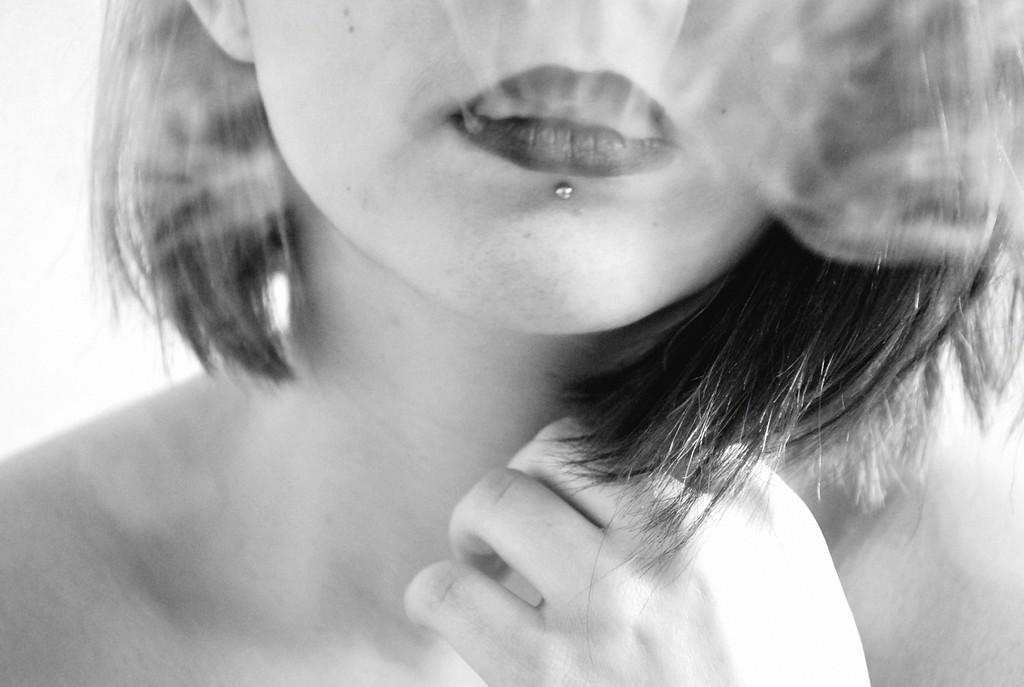Please provide a concise description of this image. In the picture we can see a mouth and neck part of a woman and we can also see her hand, keeping on the neck, and under her lip we can see a steel hook. 